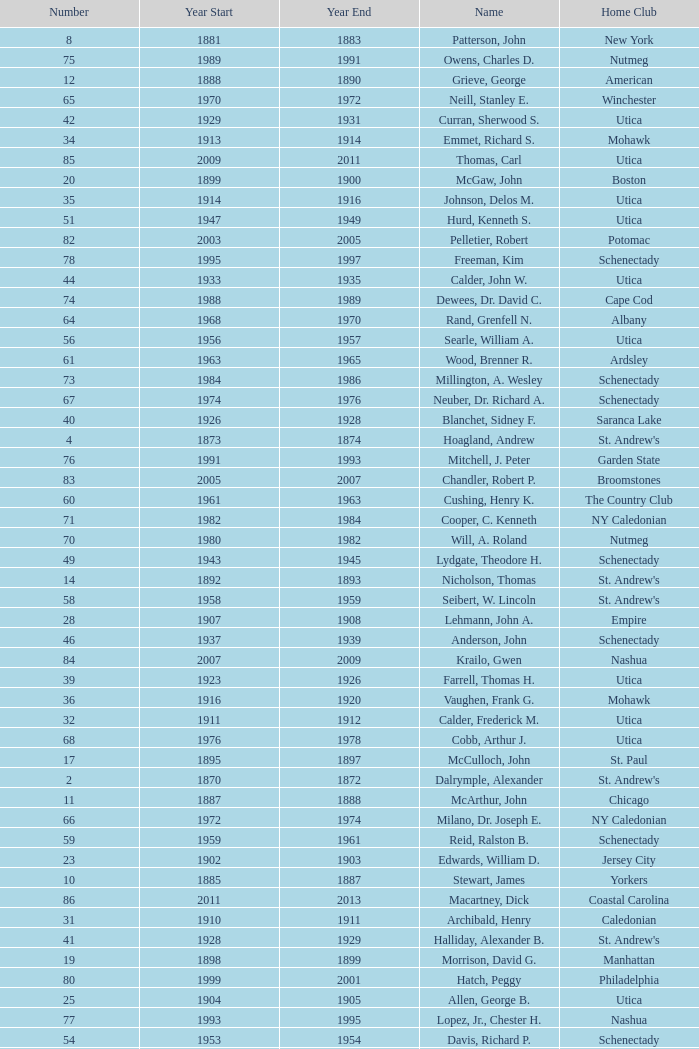Which Number has a Year Start smaller than 1874, and a Year End larger than 1873? 4.0. 